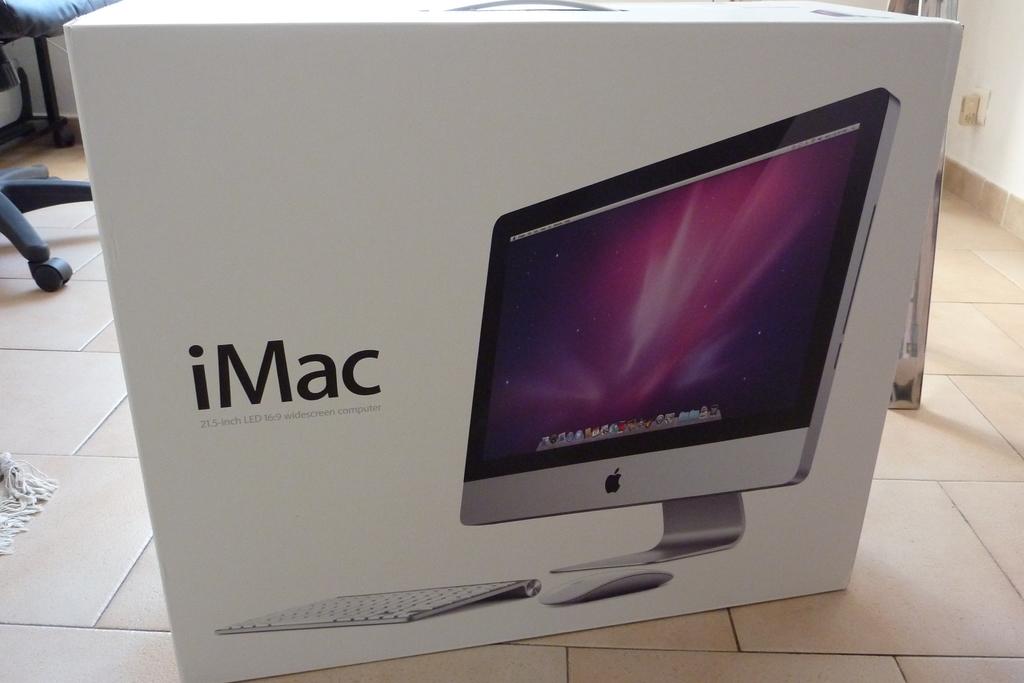What brand of electronics is this?
Your answer should be compact. Imac. 